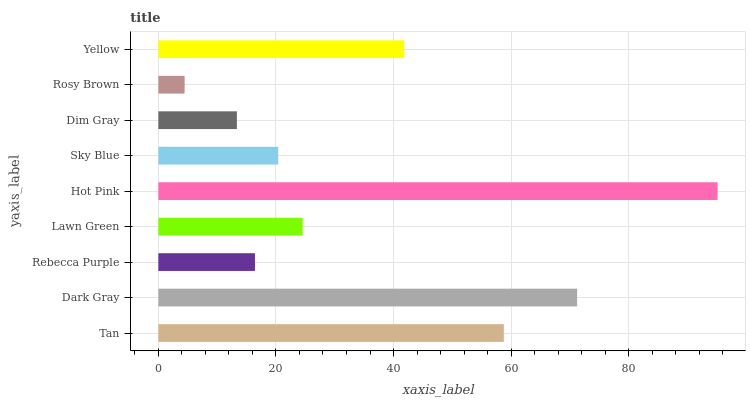Is Rosy Brown the minimum?
Answer yes or no. Yes. Is Hot Pink the maximum?
Answer yes or no. Yes. Is Dark Gray the minimum?
Answer yes or no. No. Is Dark Gray the maximum?
Answer yes or no. No. Is Dark Gray greater than Tan?
Answer yes or no. Yes. Is Tan less than Dark Gray?
Answer yes or no. Yes. Is Tan greater than Dark Gray?
Answer yes or no. No. Is Dark Gray less than Tan?
Answer yes or no. No. Is Lawn Green the high median?
Answer yes or no. Yes. Is Lawn Green the low median?
Answer yes or no. Yes. Is Dim Gray the high median?
Answer yes or no. No. Is Yellow the low median?
Answer yes or no. No. 